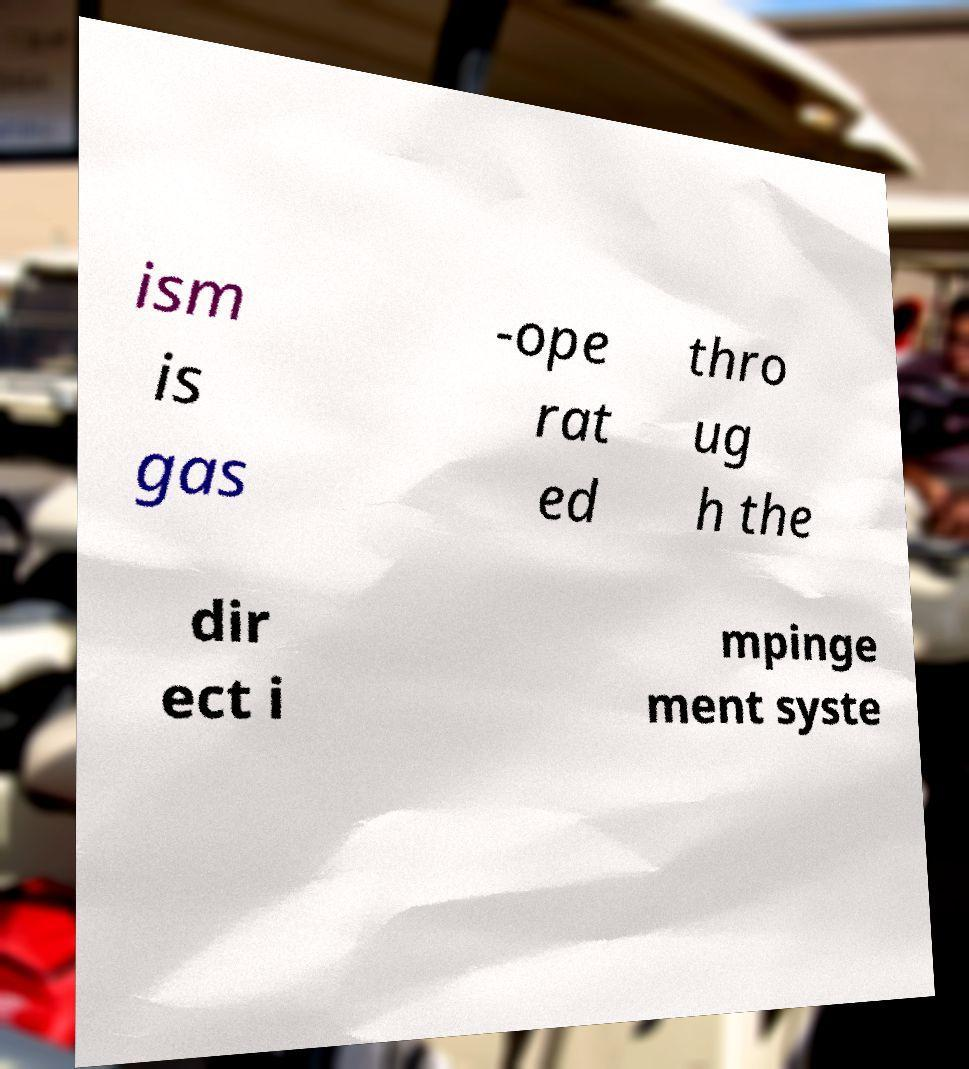For documentation purposes, I need the text within this image transcribed. Could you provide that? ism is gas -ope rat ed thro ug h the dir ect i mpinge ment syste 